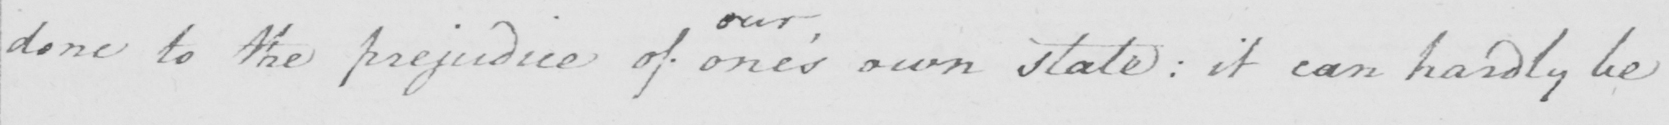Can you tell me what this handwritten text says? done to the prejudice of one ' s own state  :  it can hardly be 